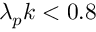<formula> <loc_0><loc_0><loc_500><loc_500>\lambda _ { p } k < 0 . 8</formula> 